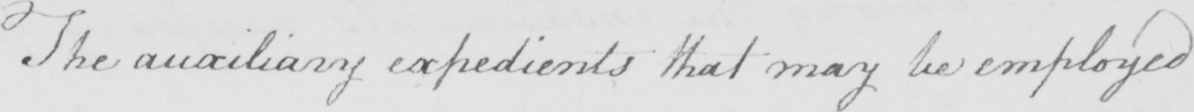What does this handwritten line say? The auxiliary expedients that may be employed 